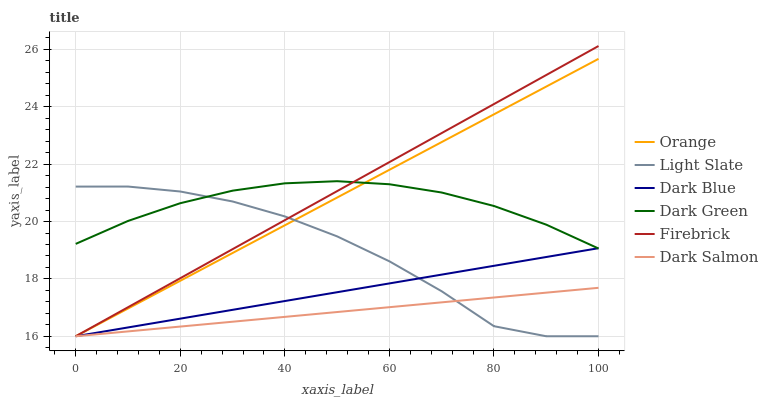Does Dark Salmon have the minimum area under the curve?
Answer yes or no. Yes. Does Firebrick have the maximum area under the curve?
Answer yes or no. Yes. Does Firebrick have the minimum area under the curve?
Answer yes or no. No. Does Dark Salmon have the maximum area under the curve?
Answer yes or no. No. Is Dark Salmon the smoothest?
Answer yes or no. Yes. Is Light Slate the roughest?
Answer yes or no. Yes. Is Firebrick the smoothest?
Answer yes or no. No. Is Firebrick the roughest?
Answer yes or no. No. Does Light Slate have the lowest value?
Answer yes or no. Yes. Does Dark Green have the lowest value?
Answer yes or no. No. Does Firebrick have the highest value?
Answer yes or no. Yes. Does Dark Salmon have the highest value?
Answer yes or no. No. Is Dark Salmon less than Dark Green?
Answer yes or no. Yes. Is Dark Green greater than Dark Salmon?
Answer yes or no. Yes. Does Light Slate intersect Dark Green?
Answer yes or no. Yes. Is Light Slate less than Dark Green?
Answer yes or no. No. Is Light Slate greater than Dark Green?
Answer yes or no. No. Does Dark Salmon intersect Dark Green?
Answer yes or no. No. 